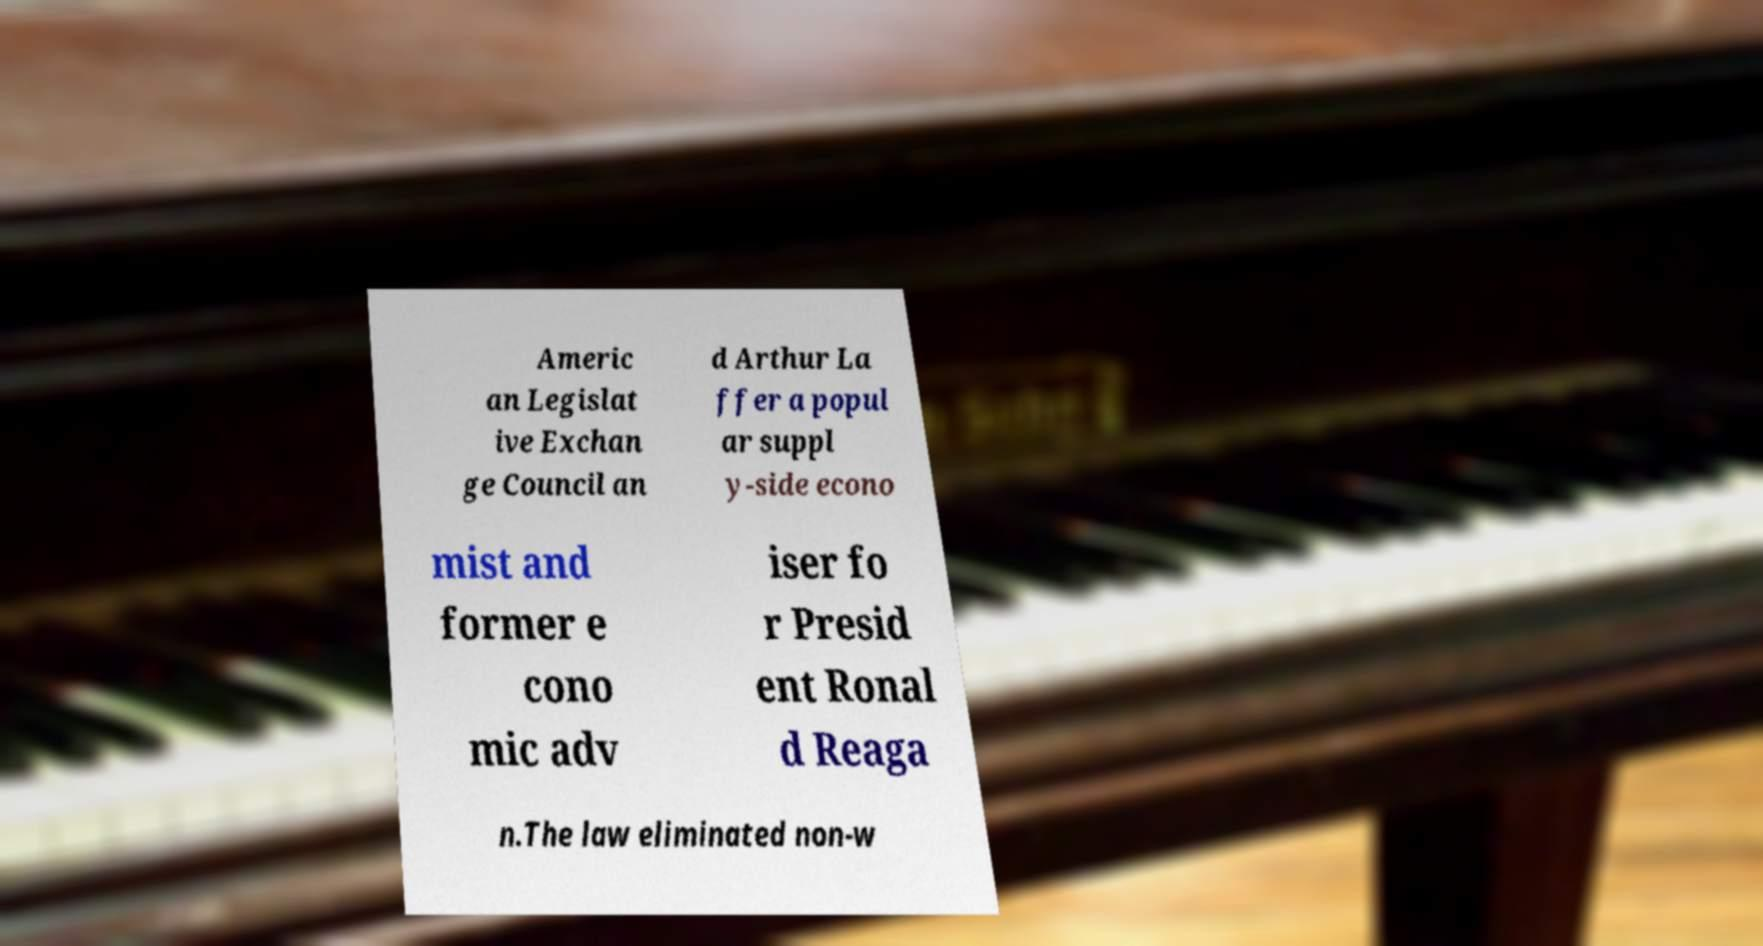Could you assist in decoding the text presented in this image and type it out clearly? Americ an Legislat ive Exchan ge Council an d Arthur La ffer a popul ar suppl y-side econo mist and former e cono mic adv iser fo r Presid ent Ronal d Reaga n.The law eliminated non-w 